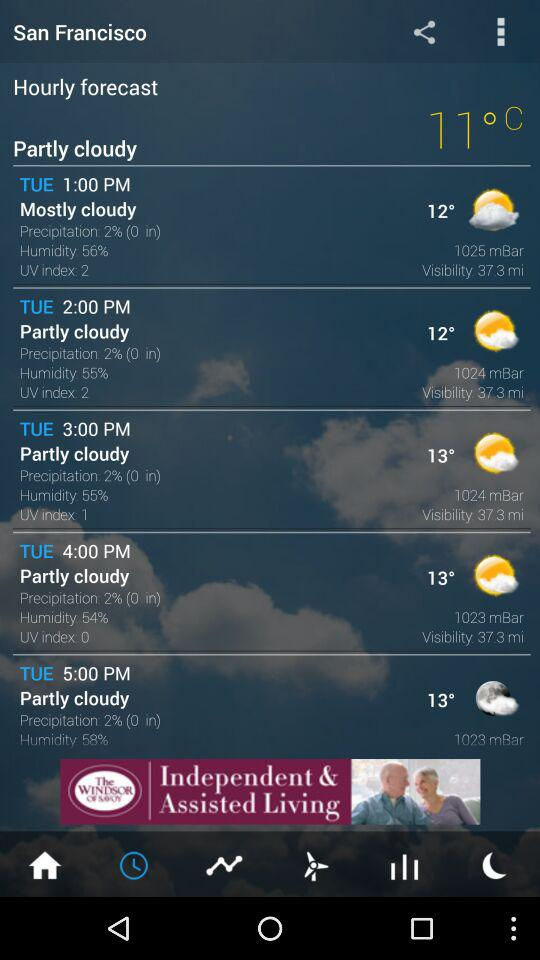How much is the humidity on Tuesday at 2:00 PM? The humidity on Tuesday at 2:00 PM is 55%. 